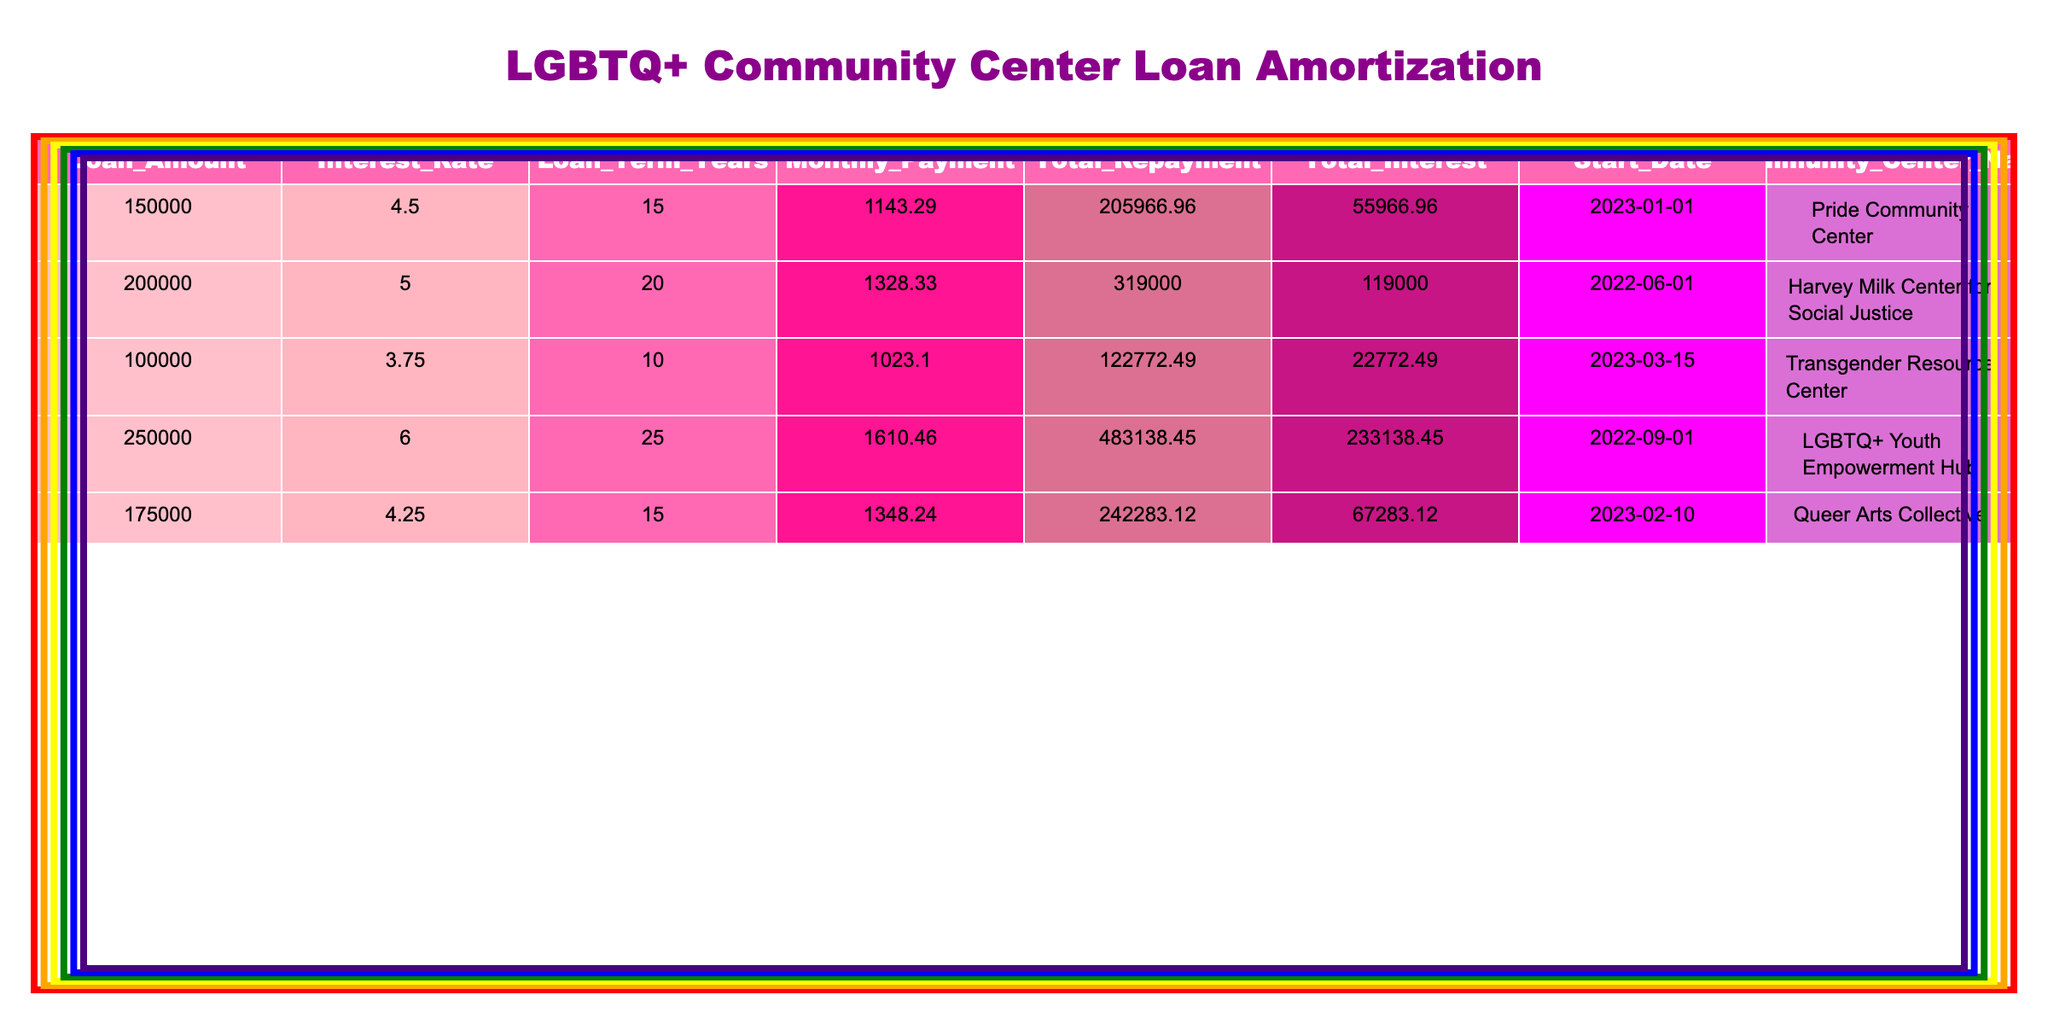What is the total repayment amount for the Pride Community Center? The total repayment amount is directly provided in the table under the "Total Repayment" column for the Pride Community Center. It is listed as 205966.96.
Answer: 205966.96 What is the loan amount for the LGBTQ+ Youth Empowerment Hub? The loan amount can be found in the "Loan Amount" column for the LGBTQ+ Youth Empowerment Hub, which is listed as 250000.
Answer: 250000 Which community center has the highest total interest? By comparing the "Total Interest" values across the community centers, the LGBTQ+ Youth Empowerment Hub has the highest total interest at 233138.45.
Answer: LGBTQ+ Youth Empowerment Hub Is the interest rate of the Transgender Resource Center lower than 5%? The interest rate for the Transgender Resource Center is listed as 3.75%, which is indeed lower than 5%. Therefore, the statement is true.
Answer: Yes What is the average monthly payment for all community centers? To find the average monthly payment, add the monthly payments of all centers: 1143.29 + 1328.33 + 1023.10 + 1610.46 + 1348.24 = 5453.42. There are 5 centers, so divide by 5: 5453.42 / 5 = 1090.68.
Answer: 1090.68 What is the difference between the total repayment for the Harvey Milk Center for Social Justice and the Queer Arts Collective? The total repayment for the Harvey Milk Center is 319000.00, and for the Queer Arts Collective, it is 242283.12. The difference is calculated as 319000.00 - 242283.12 = 76716.88.
Answer: 76716.88 Which community center has the longest loan term, and what is that term in years? The LGBTQ+ Youth Empowerment Hub has the longest loan term at 25 years, as indicated in the "Loan Term Years" column.
Answer: 25 years Do any community centers have a monthly payment exceeding 1500? By inspecting the "Monthly Payment" column, we see that the LGBTQ+ Youth Empowerment Hub’s monthly payment is 1610.46, which exceeds 1500. Therefore, the answer is yes.
Answer: Yes What will be the total interest for the loan taken by the Pride Community Center? The total interest for the Pride Community Center is listed in the table as 55966.96.
Answer: 55966.96 